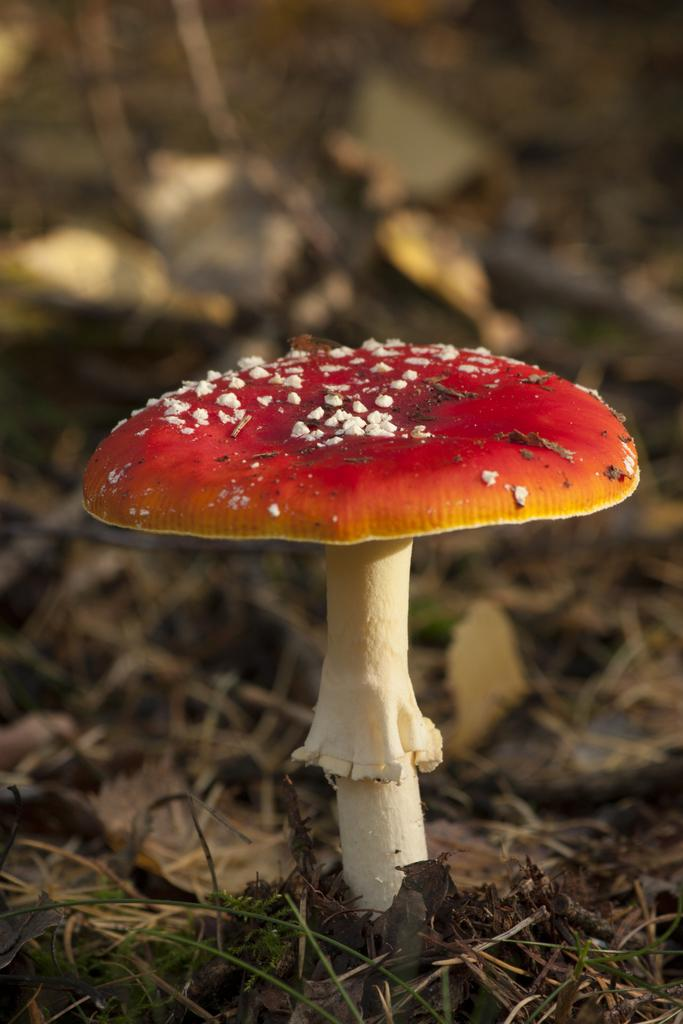What is the main subject in the center of the image? There is a mushroom in the center of the image. What can be seen in the background of the image? There are dry leaves and grass in the background of the image. What is the ground like in the image? The ground is visible in the background of the image. What type of zinc is present on the table in the image? There is no table or zinc present in the image; it features a mushroom and background elements. Who is the partner of the mushroom in the image? There is no partner for the mushroom in the image; it is a single subject. 